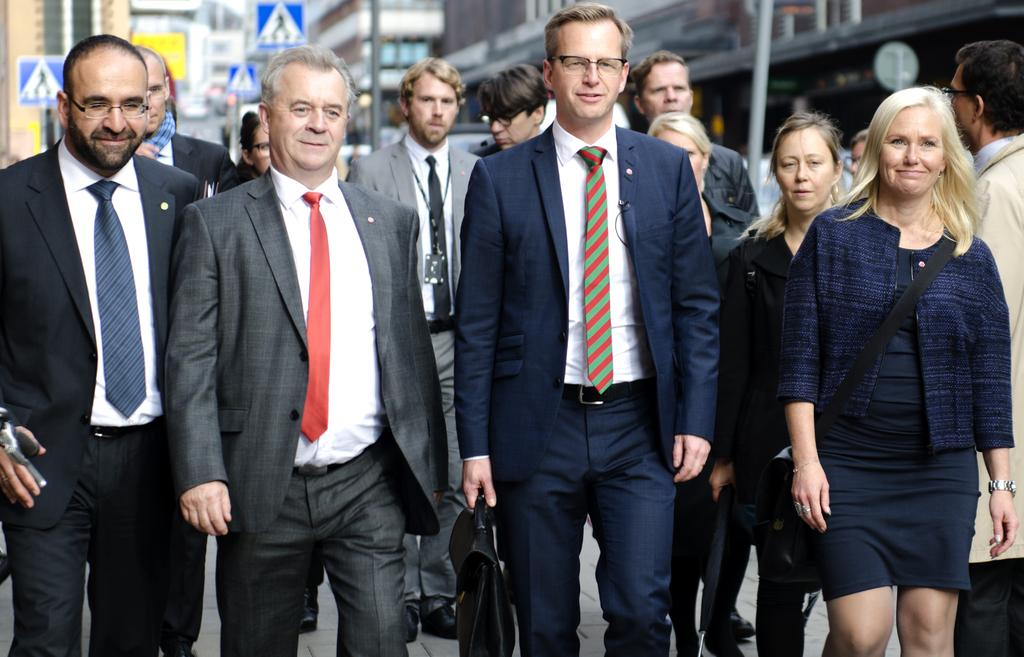What is located in the foreground of the image? There are people in the foreground of the image. What can be seen in the background of the image? There are buildings and poles in the background of the image. What type of haircut is the leaf getting in the image? There is no leaf or haircut present in the image. Can you describe the airplane flying in the background of the image? There is no airplane present in the image; only people, buildings, and poles can be seen. 